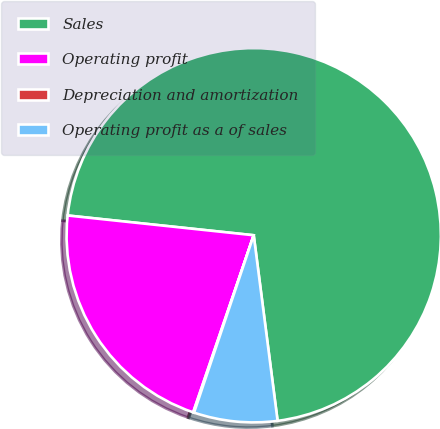Convert chart to OTSL. <chart><loc_0><loc_0><loc_500><loc_500><pie_chart><fcel>Sales<fcel>Operating profit<fcel>Depreciation and amortization<fcel>Operating profit as a of sales<nl><fcel>71.28%<fcel>21.44%<fcel>0.08%<fcel>7.2%<nl></chart> 